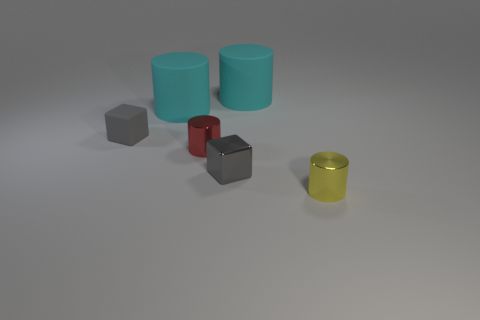Add 1 purple things. How many objects exist? 7 Subtract all gray cylinders. Subtract all green spheres. How many cylinders are left? 4 Subtract all cubes. How many objects are left? 4 Subtract 0 yellow balls. How many objects are left? 6 Subtract all small gray cubes. Subtract all yellow metallic cylinders. How many objects are left? 3 Add 1 big cylinders. How many big cylinders are left? 3 Add 6 small gray rubber cubes. How many small gray rubber cubes exist? 7 